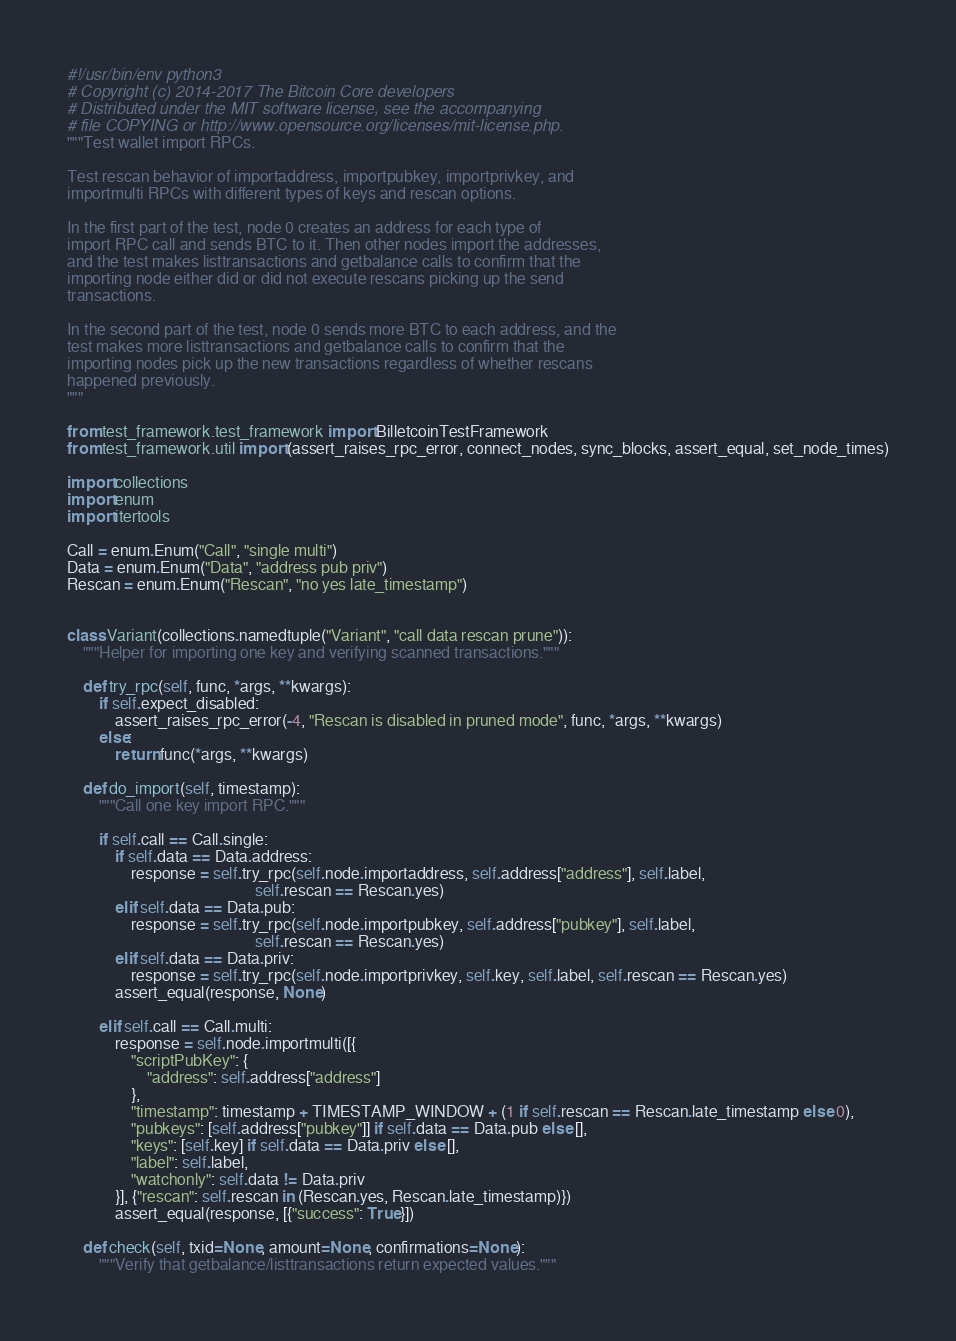Convert code to text. <code><loc_0><loc_0><loc_500><loc_500><_Python_>#!/usr/bin/env python3
# Copyright (c) 2014-2017 The Bitcoin Core developers
# Distributed under the MIT software license, see the accompanying
# file COPYING or http://www.opensource.org/licenses/mit-license.php.
"""Test wallet import RPCs.

Test rescan behavior of importaddress, importpubkey, importprivkey, and
importmulti RPCs with different types of keys and rescan options.

In the first part of the test, node 0 creates an address for each type of
import RPC call and sends BTC to it. Then other nodes import the addresses,
and the test makes listtransactions and getbalance calls to confirm that the
importing node either did or did not execute rescans picking up the send
transactions.

In the second part of the test, node 0 sends more BTC to each address, and the
test makes more listtransactions and getbalance calls to confirm that the
importing nodes pick up the new transactions regardless of whether rescans
happened previously.
"""

from test_framework.test_framework import BilletcoinTestFramework
from test_framework.util import (assert_raises_rpc_error, connect_nodes, sync_blocks, assert_equal, set_node_times)

import collections
import enum
import itertools

Call = enum.Enum("Call", "single multi")
Data = enum.Enum("Data", "address pub priv")
Rescan = enum.Enum("Rescan", "no yes late_timestamp")


class Variant(collections.namedtuple("Variant", "call data rescan prune")):
    """Helper for importing one key and verifying scanned transactions."""

    def try_rpc(self, func, *args, **kwargs):
        if self.expect_disabled:
            assert_raises_rpc_error(-4, "Rescan is disabled in pruned mode", func, *args, **kwargs)
        else:
            return func(*args, **kwargs)

    def do_import(self, timestamp):
        """Call one key import RPC."""

        if self.call == Call.single:
            if self.data == Data.address:
                response = self.try_rpc(self.node.importaddress, self.address["address"], self.label,
                                               self.rescan == Rescan.yes)
            elif self.data == Data.pub:
                response = self.try_rpc(self.node.importpubkey, self.address["pubkey"], self.label,
                                               self.rescan == Rescan.yes)
            elif self.data == Data.priv:
                response = self.try_rpc(self.node.importprivkey, self.key, self.label, self.rescan == Rescan.yes)
            assert_equal(response, None)

        elif self.call == Call.multi:
            response = self.node.importmulti([{
                "scriptPubKey": {
                    "address": self.address["address"]
                },
                "timestamp": timestamp + TIMESTAMP_WINDOW + (1 if self.rescan == Rescan.late_timestamp else 0),
                "pubkeys": [self.address["pubkey"]] if self.data == Data.pub else [],
                "keys": [self.key] if self.data == Data.priv else [],
                "label": self.label,
                "watchonly": self.data != Data.priv
            }], {"rescan": self.rescan in (Rescan.yes, Rescan.late_timestamp)})
            assert_equal(response, [{"success": True}])

    def check(self, txid=None, amount=None, confirmations=None):
        """Verify that getbalance/listtransactions return expected values."""
</code> 